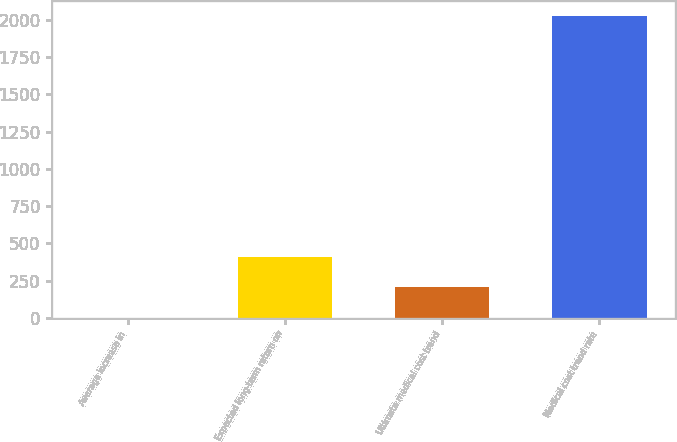Convert chart to OTSL. <chart><loc_0><loc_0><loc_500><loc_500><bar_chart><fcel>Average increase in<fcel>Expected long-term return on<fcel>Ultimate medical cost trend<fcel>Medical cost trend rate<nl><fcel>3.5<fcel>408.4<fcel>205.95<fcel>2028<nl></chart> 